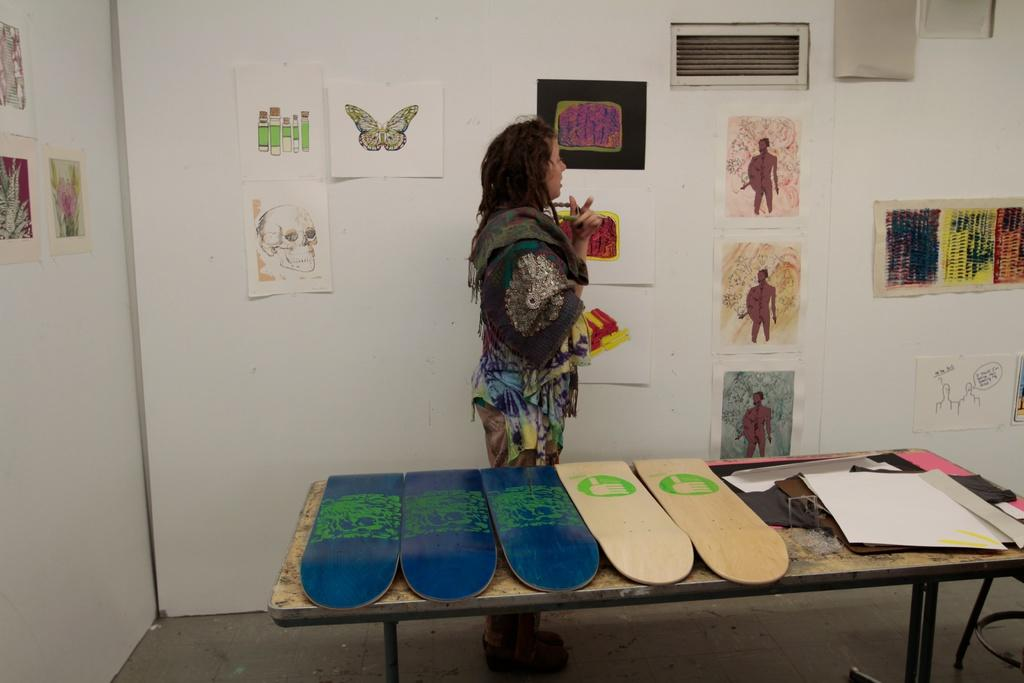Who is the main subject in the image? There is a woman in the image. What is the woman doing in the image? The woman is explaining something. What can be seen on the papers in the image? There are drawings on the papers. Where are the papers with drawings located in the image? The papers are pasted on the wall. What type of vegetable is growing on the wall in the image? There are no vegetables growing on the wall in the image; it features papers with drawings pasted on it. 